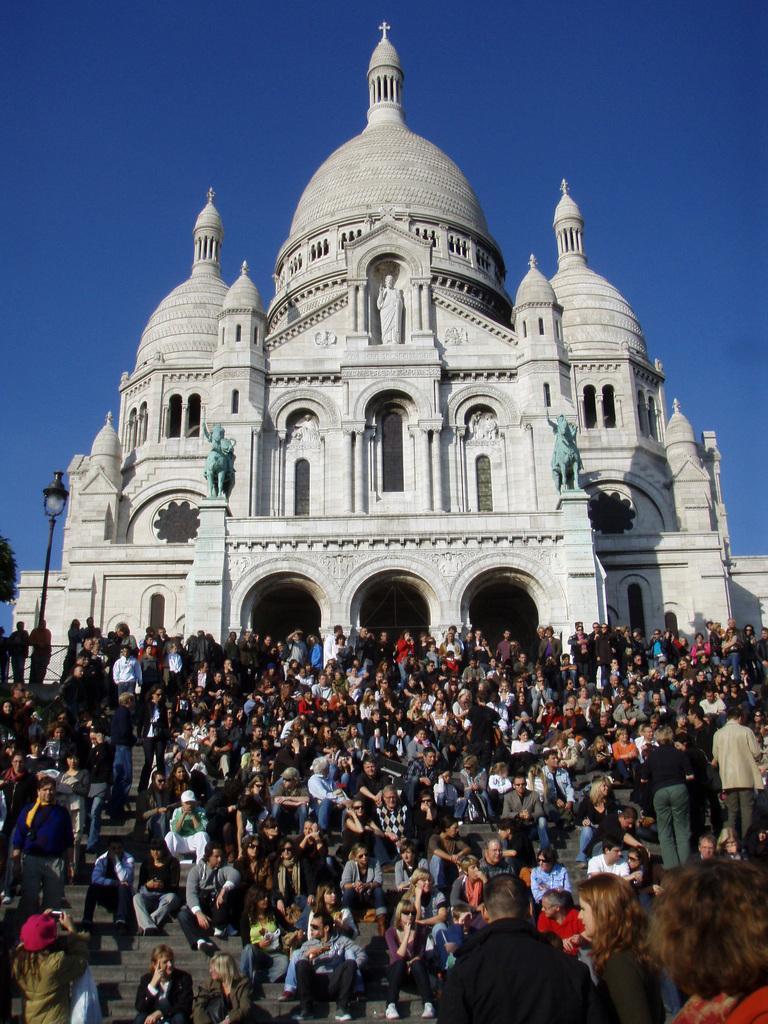Can you describe this image briefly? In this image there is the sky truncated towards the top of the image, there is a building, there are sculptures on the building, there are group of persons on the staircase, there are persons truncated towards the bottom of the image, there are persons truncated towards the right of the image, there are persons truncated towards the left of the image, there are persons holding an object, there is a light, there is a pole, there is an object truncated towards the left of the image. 